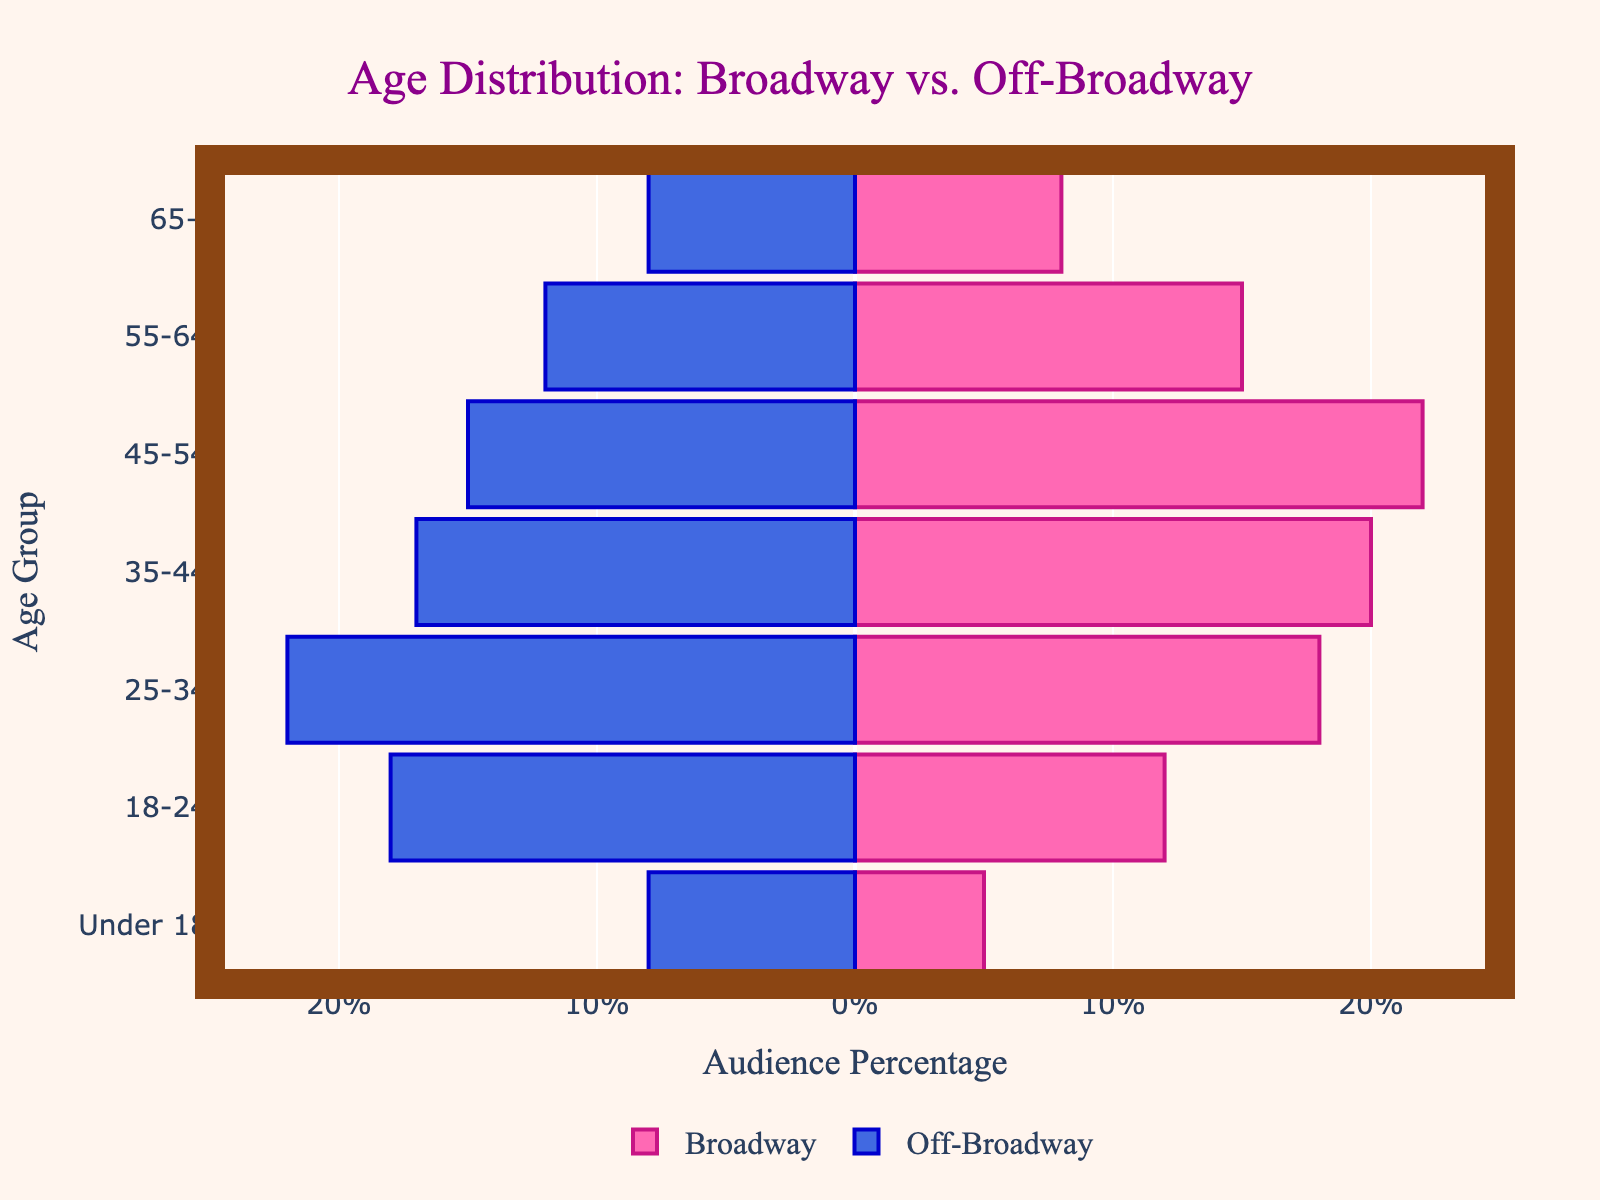How many age groups are represented in the figure? The figure lists specific age ranges along the y-axis. Counting these distinct categories will give the number of age groups.
Answer: 7 What is the title of the figure? The title is prominently displayed at the top of the figure and helps to understand the context of the data presented.
Answer: Age Distribution: Broadway vs. Off-Broadway Which age group has the highest audience percentage for Broadway? To find the highest percentage for Broadway, identify the age group bar that extends furthest to the right.
Answer: 45-54 Which age group has the highest audience percentage for Off-Broadway? To find the highest percentage for Off-Broadway, identify the age group bar that extends furthest to the left (negative direction).
Answer: 25-34 What is the combined percentage of audiences aged 18-24 for both Broadway and Off-Broadway? Sum the values of the 18-24 age group from both Broadway and Off-Broadway audiences to get the combined percentage. Broadway has 12%, and Off-Broadway has 18%. 12 + 18 = 30%.
Answer: 30% How do the audience percentages compare for the 35-44 age group between Broadway and Off-Broadway? Subtract the Off-Broadway value from the Broadway value for the 35-44 age group. Broadway is 20%, and Off-Broadway is 17%. 20 - 17 = 3%.
Answer: Broadway is higher by 3% Which age group has an equal percentage of audiences in both Broadway and Off-Broadway productions? Look for matching lengths of bars (ignoring the sign) for Broadway and Off-Broadway.
Answer: 65+ What is the difference in audience percentage between the youngest (Under 18) and oldest (65+) age groups for Broadway? For Broadway, subtract the percentage of the oldest age group (65+) from the youngest age group (Under 18). Under 18 is 5%, and 65+ is 8%. 5 - 8 = -3%.
Answer: -3% What is the average audience percentage for the 45-54 age group across both Broadway and Off-Broadway? Add the percentages of the 45-54 age group for both Broadway and Off-Broadway, and then divide by 2. Broadway has 22%, and Off-Broadway has 15%. (22 + 15) / 2 = 18.5%.
Answer: 18.5% Which age group shows a greater audience percentage for Off-Broadway than Broadway, and by how much? Compare each age group where Off-Broadway has a higher value than Broadway, then find the difference. The age groups 0-18, 18-24, 25-34 satisfy this, and the highest difference is for 25-34 age group, which is Off-Broadway 22%, Broadway 18% (22 - 18 = 4).
Answer: 25-34, by 4% 